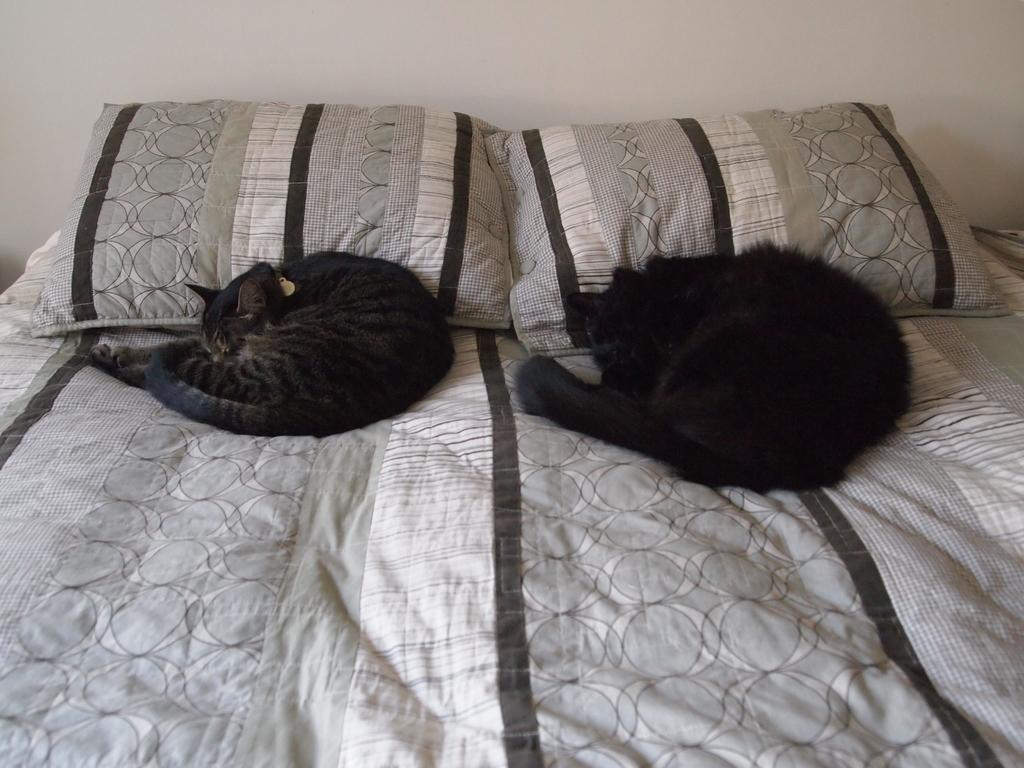How many cats are in the image? There are two cats in the image. Where are the cats located? The cats are on a bed. What else can be seen on the bed? There are two pillows on the bed. What type of breakfast is the man eating in the image? There is no man present in the image, so it is not possible to determine what, if any, breakfast might be eaten. 